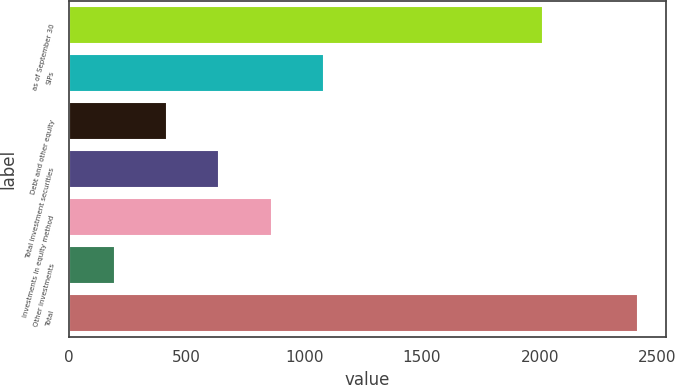Convert chart. <chart><loc_0><loc_0><loc_500><loc_500><bar_chart><fcel>as of September 30<fcel>SIPs<fcel>Debt and other equity<fcel>Total investment securities<fcel>Investments in equity method<fcel>Other investments<fcel>Total<nl><fcel>2016<fcel>1084.18<fcel>417.97<fcel>640.04<fcel>862.11<fcel>195.9<fcel>2416.6<nl></chart> 